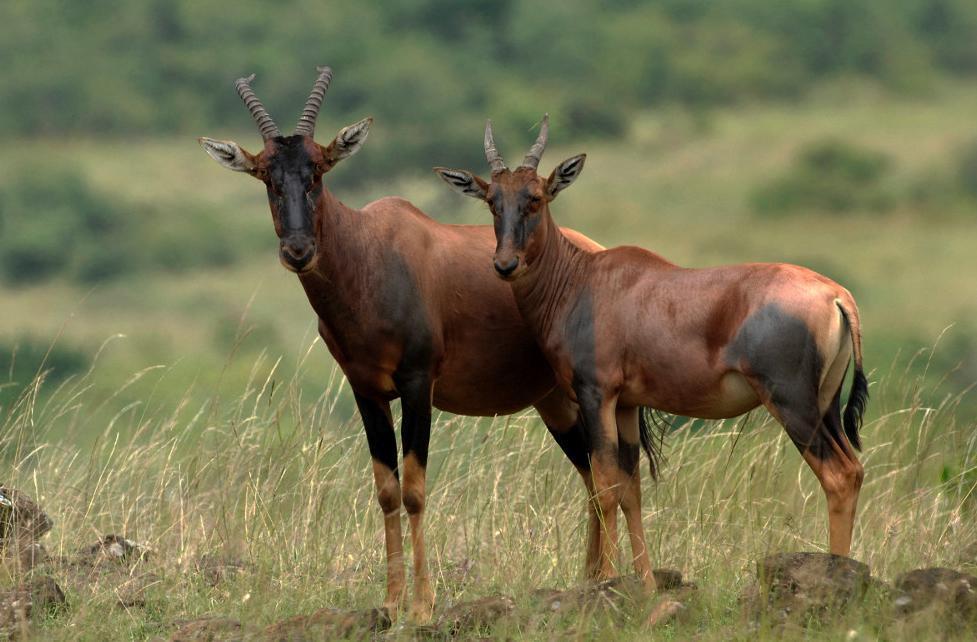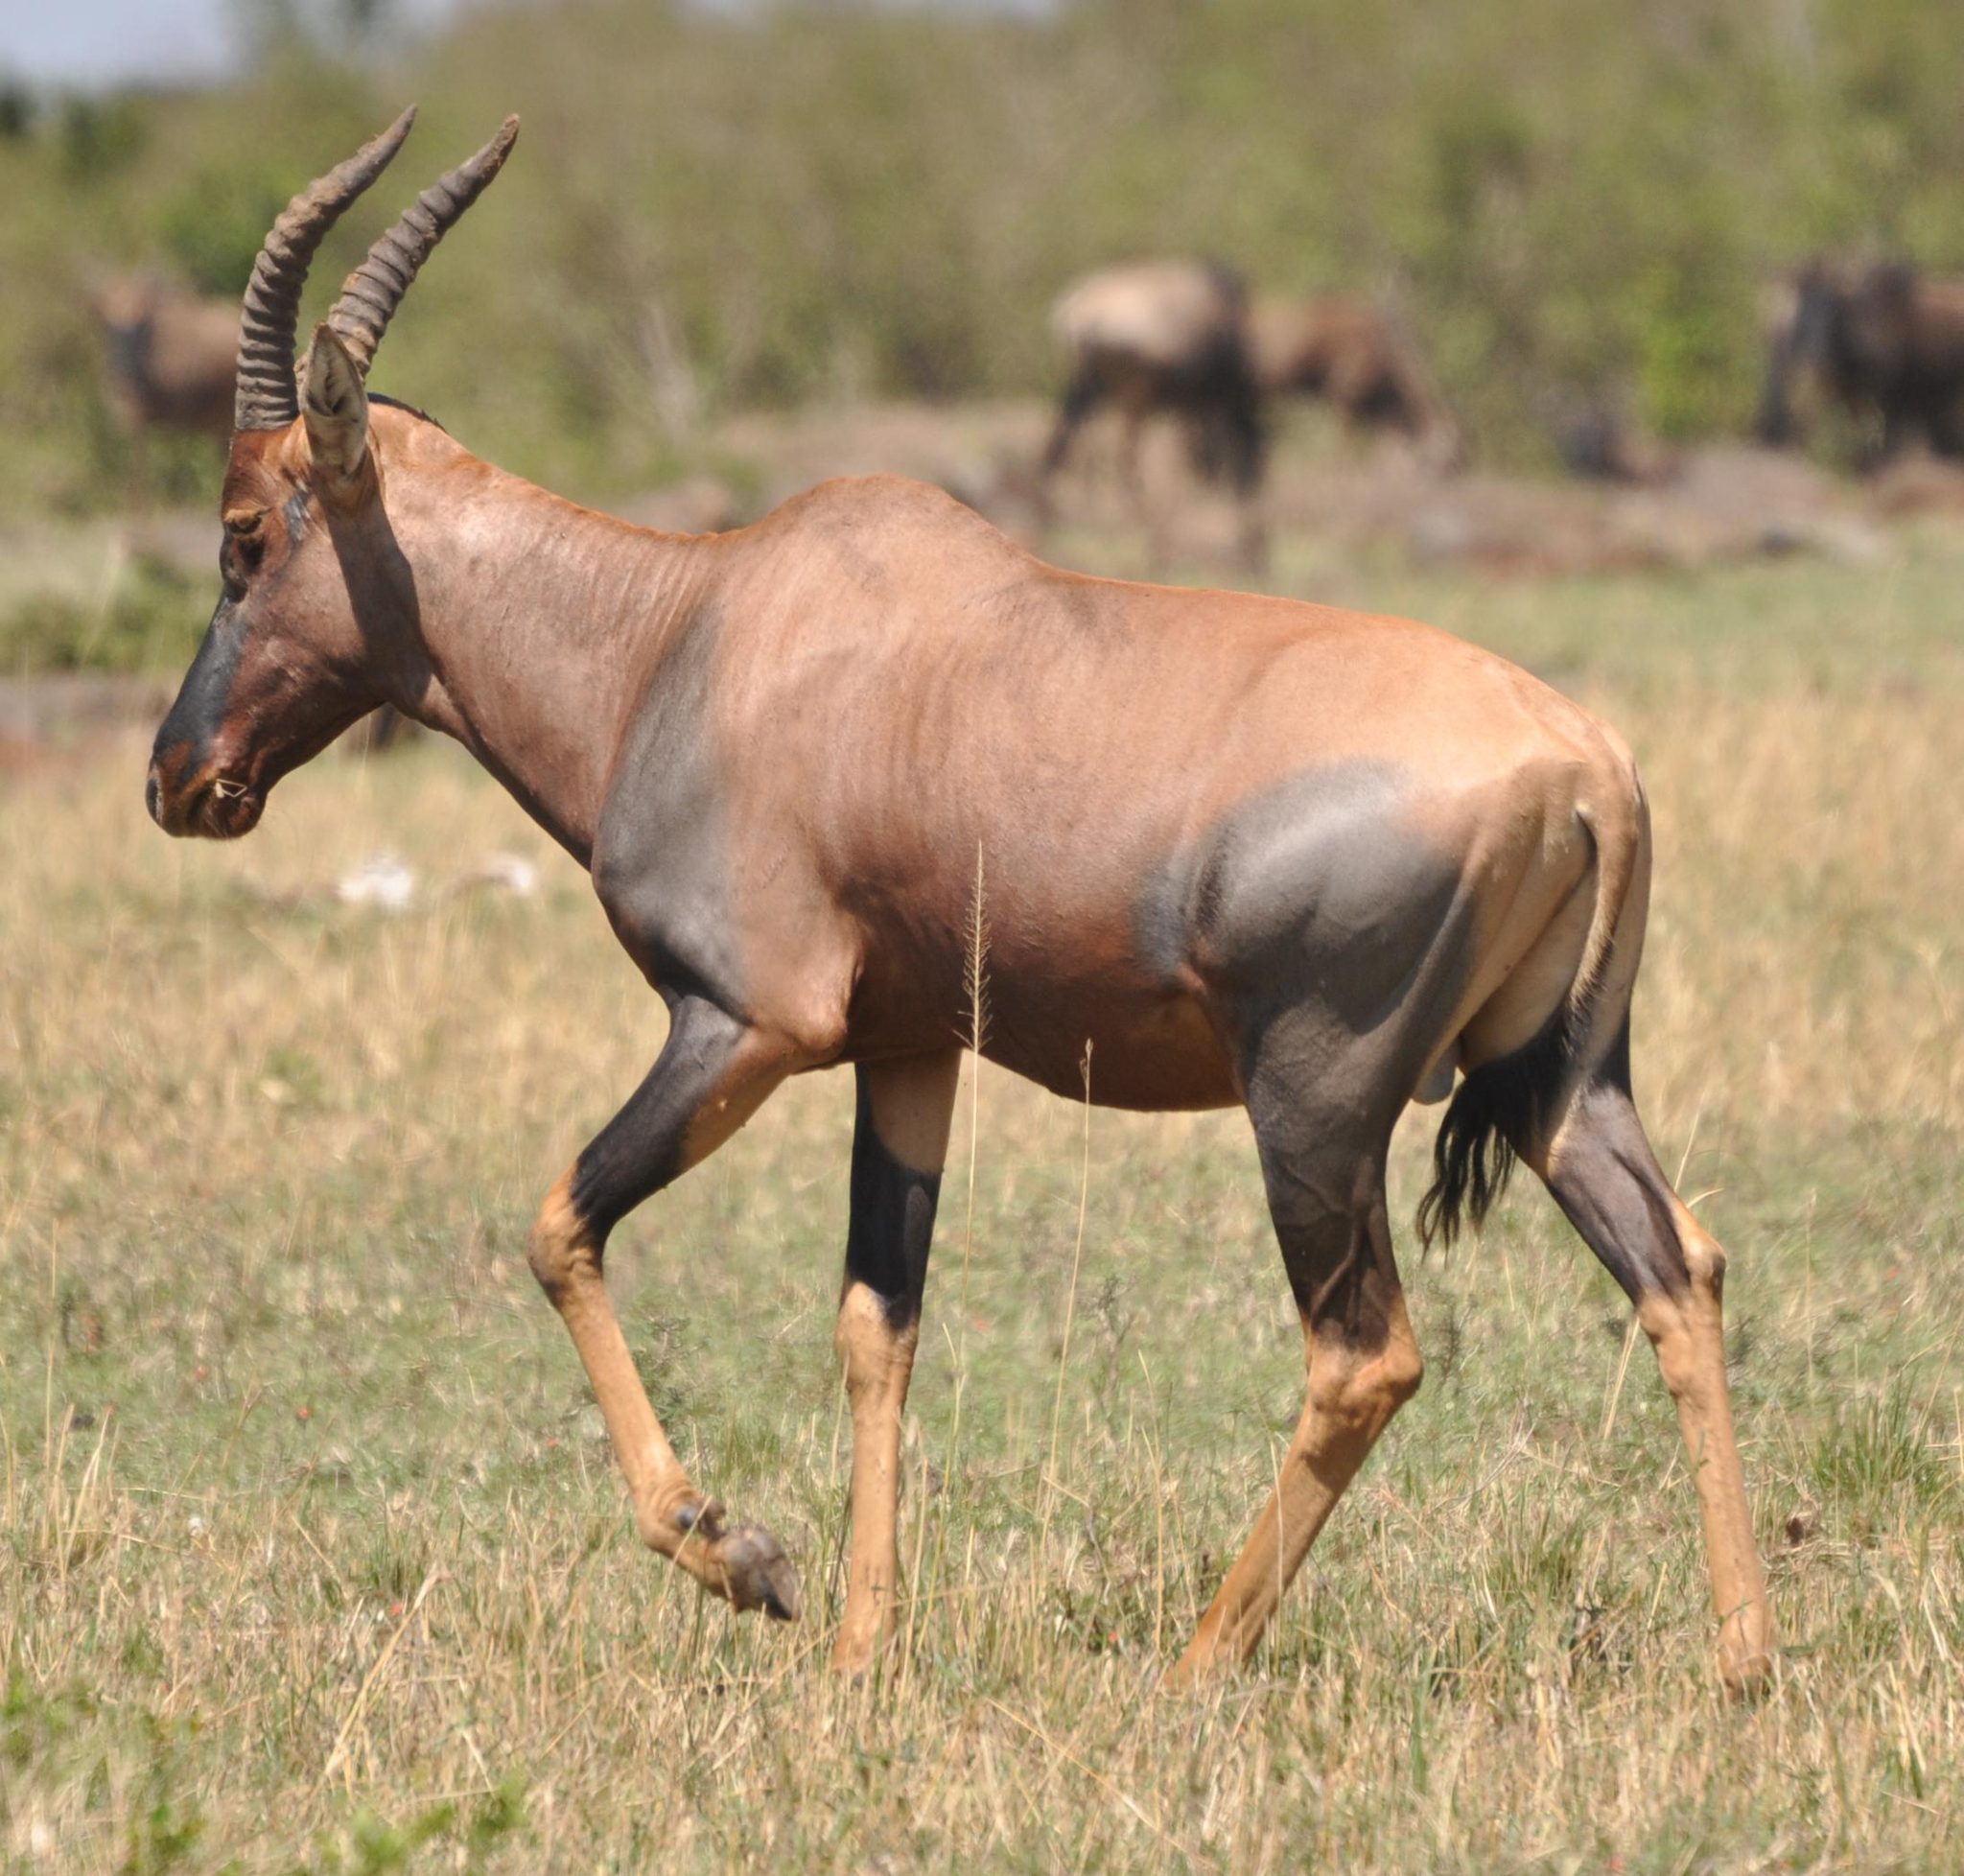The first image is the image on the left, the second image is the image on the right. For the images shown, is this caption "The left and right image contains a total of three elk." true? Answer yes or no. Yes. The first image is the image on the left, the second image is the image on the right. Given the left and right images, does the statement "One image contains exactly twice as many hooved animals in the foreground as the other image." hold true? Answer yes or no. Yes. 